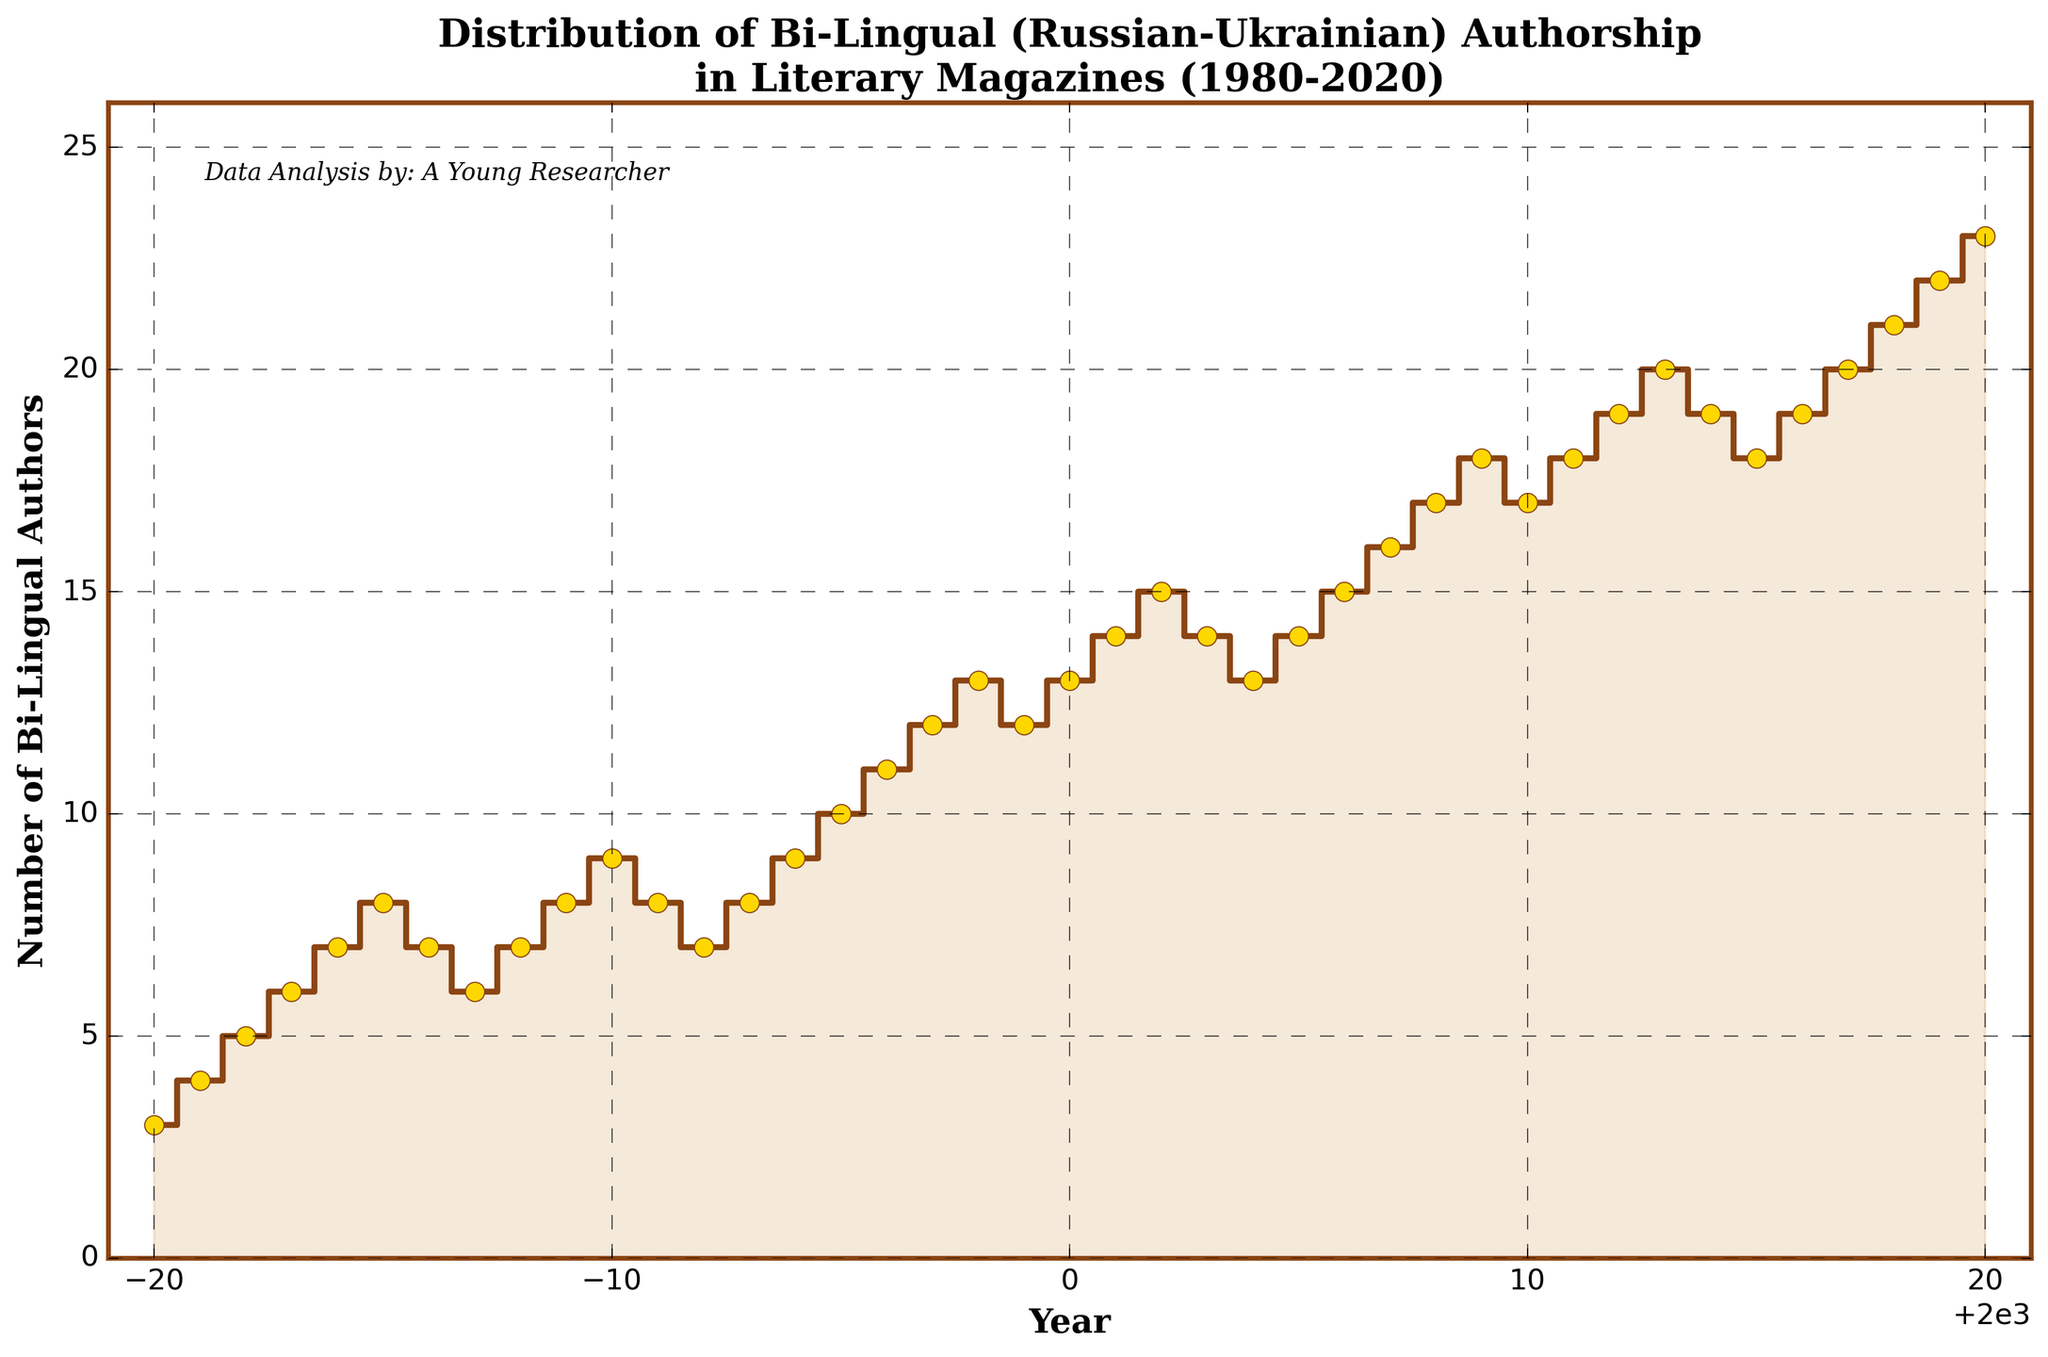What is the title of the plot? The title is usually found at the top of the figure. In this case, it reads "Distribution of Bi-Lingual (Russian-Ukrainian) Authorship in Literary Magazines (1980-2020)".
Answer: Distribution of Bi-Lingual (Russian-Ukrainian) Authorship in Literary Magazines (1980-2020) What does the x-axis represent? The x-axis represents the years from 1980 to 2020, as indicated by its label and the ticks marking each year.
Answer: Years What were the number of bi-lingual authors in 2000? To find this value, locate the year 2000 on the x-axis and refer to the corresponding value on the y-axis. The plot shows 13 bi-lingual authors for the year 2000.
Answer: 13 What is the trend observed from 1980 to 2020 in the number of bi-lingual authors? Observing the plot from left to right, there is a general increasing trend in the number of bi-lingual authors over the years 1980 to 2020.
Answer: Increasing trend Which year had the highest number of bi-lingual authors, and what was the number? Find the peak point in the plot and identify the year and the corresponding y-axis value. The plot's highest point is in the year 2020, with 23 authors.
Answer: 2020, 23 What is the difference in the number of bi-lingual authors between 1980 and 2020? The number of authors in 1980 was 3, and in 2020 it was 23. Subtract the initial value from the final value: 23 - 3 = 20.
Answer: 20 Between which consecutive years did the number of bi-lingual authors decrease? Look for downward steps in the plot. There are decreases observed between 1985-1986, 1987-1988, 1990-1991, 1991-1992, 2003-2004, 2007-2008, and 2013-2014.
Answer: 1985-1986, 1987-1988, 1990-1991, 1991-1992, 2003-2004, 2007-2008, 2013-2014 By how much did the number of bi-lingual authors increase between 1996 and 1997? The number of authors in 1996 was 11, and in 1997 it was 12. The increase is calculated by 12 - 11 = 1.
Answer: 1 Which decade saw the highest overall increase in the number of bi-lingual authors? Compare the change in the number of authors over each decade: 1980-1990 (3 to 9 = +6), 1990-2000 (9 to 13 = +4), 2000-2010 (13 to 18 = +5), and 2010-2020 (18 to 23 = +5). The decade 1980-1990 saw the highest increase of +6.
Answer: 1980-1990 